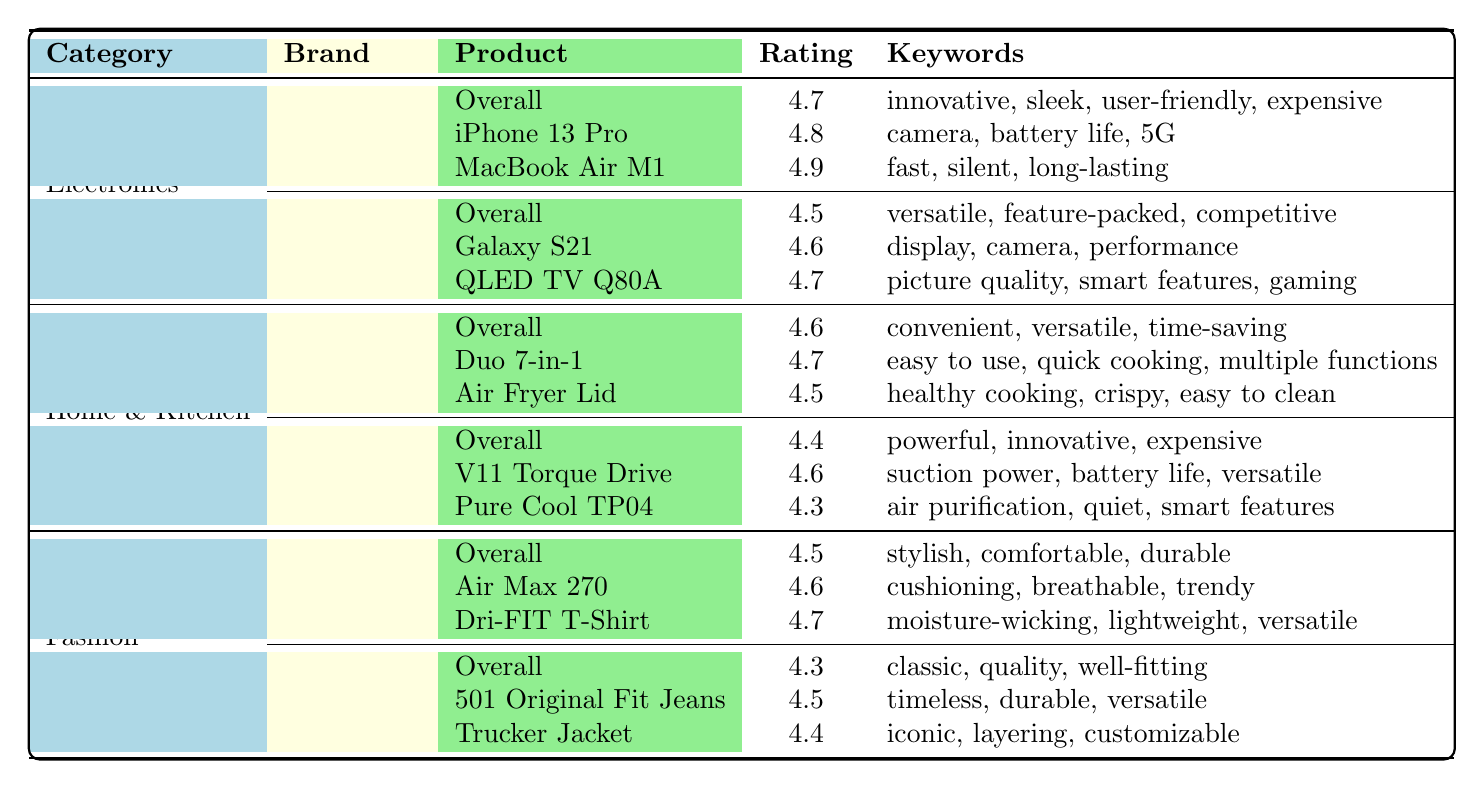What is the average rating for the Apple brand in the Electronics category? The table shows that Apple's average rating in the Electronics category is listed directly as 4.7.
Answer: 4.7 What keywords are common for Samsung products? The table indicates that the common keywords for Samsung are versatile, feature-packed, and competitive.
Answer: versatile, feature-packed, competitive Which product has the highest rating within the Dyson brand? From the table, it can be seen that the V11 Torque Drive has a rating of 4.6, which is higher than Pure Cool TP04, which has a rating of 4.3.
Answer: V11 Torque Drive Is the average rating for Instant Pot higher than that of Dyson? Instant Pot's average rating is 4.6, while Dyson's average rating is 4.4, so 4.6 > 4.4. Thus, Instant Pot has a higher average rating.
Answer: Yes How many products from the Nike brand are mentioned in the table, and what is their average rating? The table lists two products from Nike: Air Max 270 and Dri-FIT T-Shirt. Their ratings are 4.6 and 4.7, respectively. The average rating is calculated by (4.6 + 4.7) / 2 = 4.65.
Answer: 2 products; average rating is 4.65 What is the highest-rated product in the Fashion category? The table shows that the Dri-FIT T-Shirt from Nike has the highest rating of 4.7 in the Fashion category compared to Nike's other product and Levi's products.
Answer: Dri-FIT T-Shirt Are there more products listed for Instant Pot or Dyson? Instant Pot has two products listed (Duo 7-in-1 and Air Fryer Lid), while Dyson also has two products (V11 Torque Drive and Pure Cool TP04). Thus, the counts are equal.
Answer: Equal number of products What is the average rating of the products listed under the Levi's brand? Levi's products with ratings are 4.5 for 501 Original Fit Jeans and 4.4 for Trucker Jacket. The average rating is (4.5 + 4.4) / 2 = 4.45.
Answer: 4.45 Which category has the highest overall average rating, based on the values presented? The average ratings by category are 4.7 for Electronics, 4.5 for Fashion, and 4.5 for Home & Kitchen. The highest is 4.7 in Electronics.
Answer: Electronics What percentage of Samsung products have a rating equal to or above 4.6? Samsung has two products: Galaxy S21 rated at 4.6 and QLED TV Q80A rated at 4.7. Both are equal to or above 4.6, making it 2 out of 2. Thus, the percentage is (2/2)*100 = 100%.
Answer: 100% 